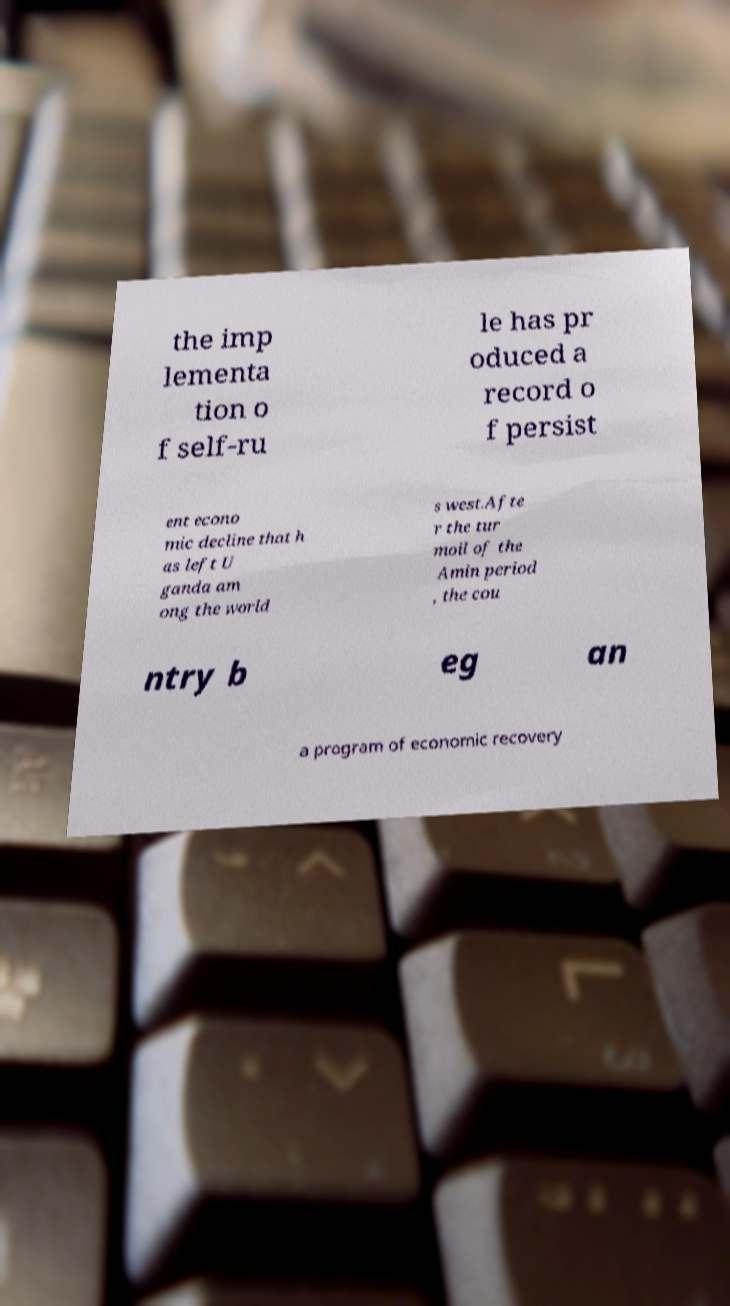Could you assist in decoding the text presented in this image and type it out clearly? the imp lementa tion o f self-ru le has pr oduced a record o f persist ent econo mic decline that h as left U ganda am ong the world s west.Afte r the tur moil of the Amin period , the cou ntry b eg an a program of economic recovery 